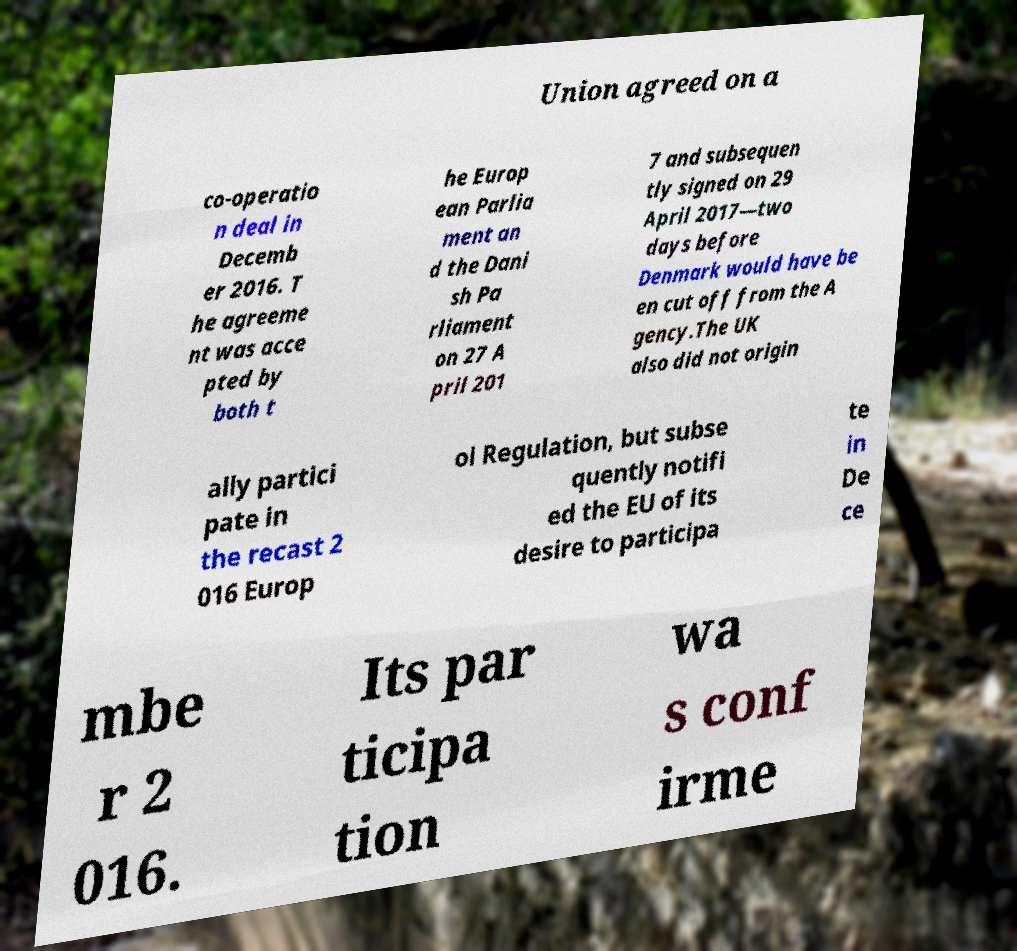There's text embedded in this image that I need extracted. Can you transcribe it verbatim? Union agreed on a co-operatio n deal in Decemb er 2016. T he agreeme nt was acce pted by both t he Europ ean Parlia ment an d the Dani sh Pa rliament on 27 A pril 201 7 and subsequen tly signed on 29 April 2017—two days before Denmark would have be en cut off from the A gency.The UK also did not origin ally partici pate in the recast 2 016 Europ ol Regulation, but subse quently notifi ed the EU of its desire to participa te in De ce mbe r 2 016. Its par ticipa tion wa s conf irme 